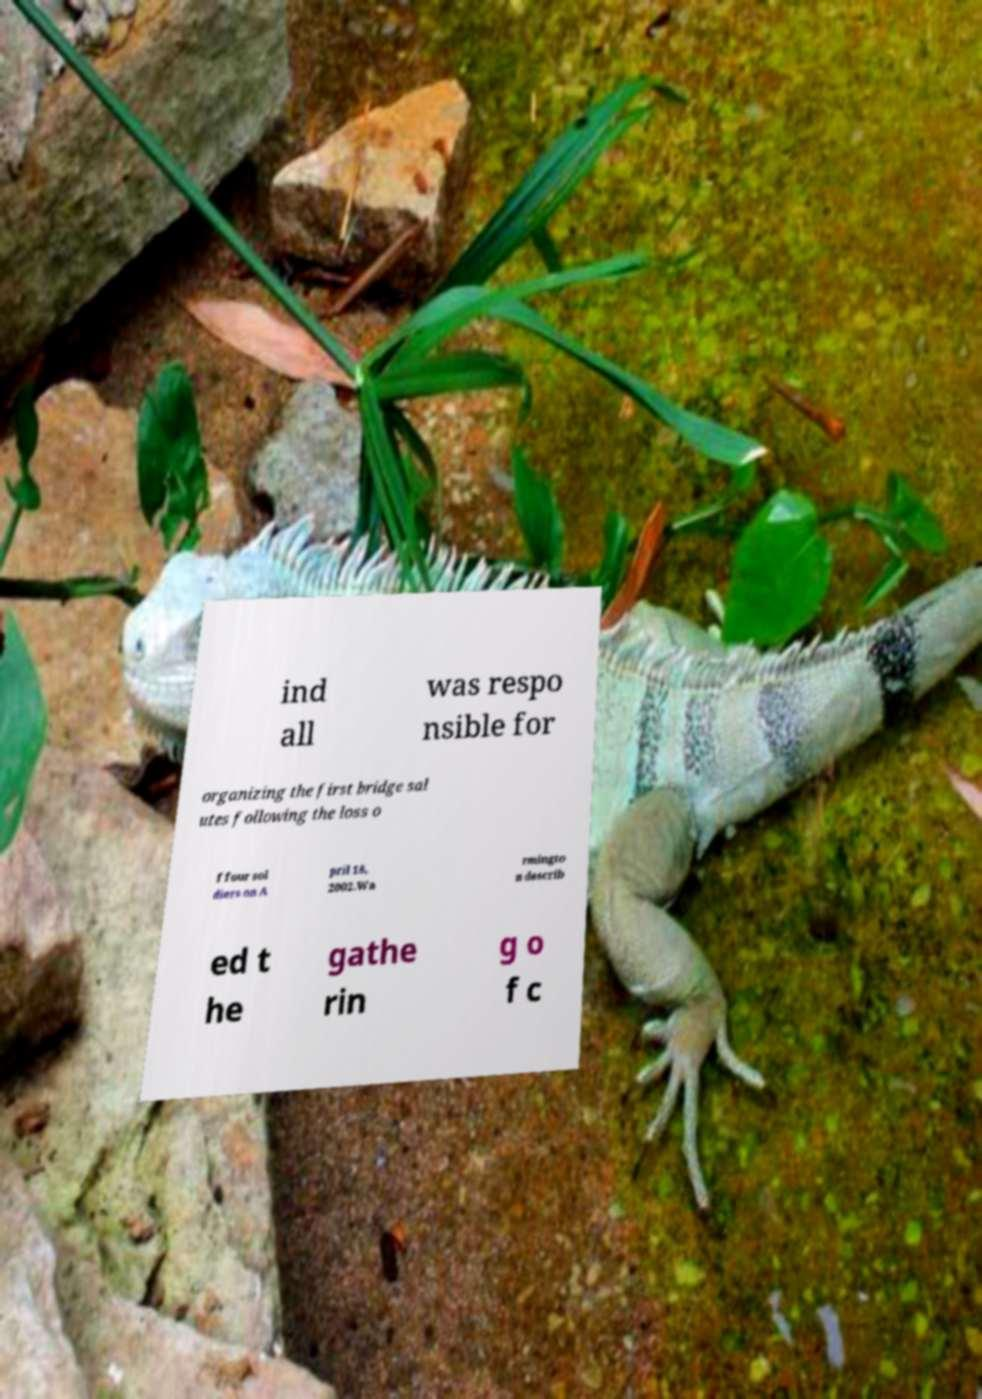Can you accurately transcribe the text from the provided image for me? ind all was respo nsible for organizing the first bridge sal utes following the loss o f four sol diers on A pril 18, 2002.Wa rmingto n describ ed t he gathe rin g o f c 